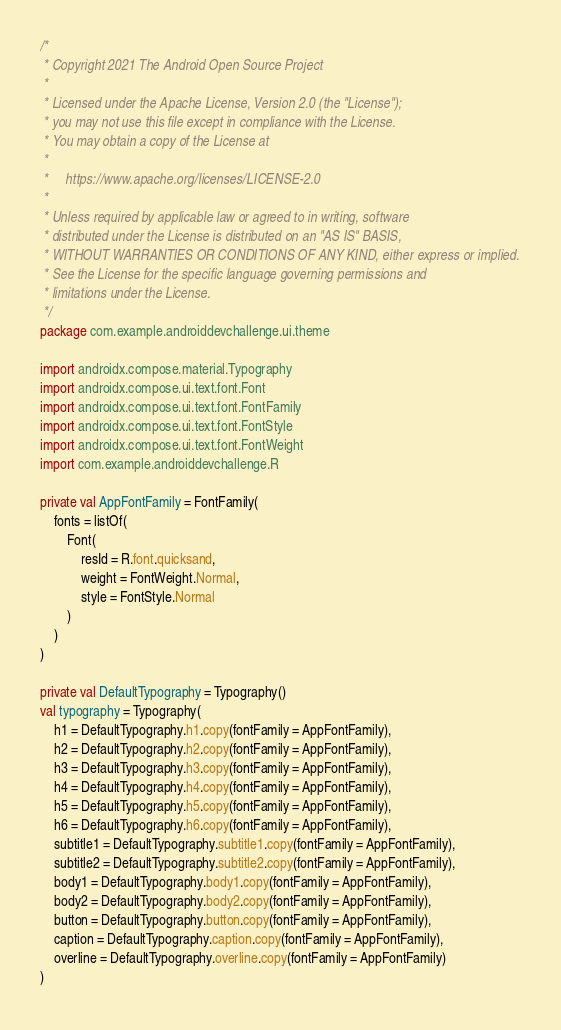Convert code to text. <code><loc_0><loc_0><loc_500><loc_500><_Kotlin_>/*
 * Copyright 2021 The Android Open Source Project
 *
 * Licensed under the Apache License, Version 2.0 (the "License");
 * you may not use this file except in compliance with the License.
 * You may obtain a copy of the License at
 *
 *     https://www.apache.org/licenses/LICENSE-2.0
 *
 * Unless required by applicable law or agreed to in writing, software
 * distributed under the License is distributed on an "AS IS" BASIS,
 * WITHOUT WARRANTIES OR CONDITIONS OF ANY KIND, either express or implied.
 * See the License for the specific language governing permissions and
 * limitations under the License.
 */
package com.example.androiddevchallenge.ui.theme

import androidx.compose.material.Typography
import androidx.compose.ui.text.font.Font
import androidx.compose.ui.text.font.FontFamily
import androidx.compose.ui.text.font.FontStyle
import androidx.compose.ui.text.font.FontWeight
import com.example.androiddevchallenge.R

private val AppFontFamily = FontFamily(
    fonts = listOf(
        Font(
            resId = R.font.quicksand,
            weight = FontWeight.Normal,
            style = FontStyle.Normal
        )
    )
)

private val DefaultTypography = Typography()
val typography = Typography(
    h1 = DefaultTypography.h1.copy(fontFamily = AppFontFamily),
    h2 = DefaultTypography.h2.copy(fontFamily = AppFontFamily),
    h3 = DefaultTypography.h3.copy(fontFamily = AppFontFamily),
    h4 = DefaultTypography.h4.copy(fontFamily = AppFontFamily),
    h5 = DefaultTypography.h5.copy(fontFamily = AppFontFamily),
    h6 = DefaultTypography.h6.copy(fontFamily = AppFontFamily),
    subtitle1 = DefaultTypography.subtitle1.copy(fontFamily = AppFontFamily),
    subtitle2 = DefaultTypography.subtitle2.copy(fontFamily = AppFontFamily),
    body1 = DefaultTypography.body1.copy(fontFamily = AppFontFamily),
    body2 = DefaultTypography.body2.copy(fontFamily = AppFontFamily),
    button = DefaultTypography.button.copy(fontFamily = AppFontFamily),
    caption = DefaultTypography.caption.copy(fontFamily = AppFontFamily),
    overline = DefaultTypography.overline.copy(fontFamily = AppFontFamily)
)
</code> 